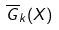<formula> <loc_0><loc_0><loc_500><loc_500>\overline { G } _ { k } ( X )</formula> 